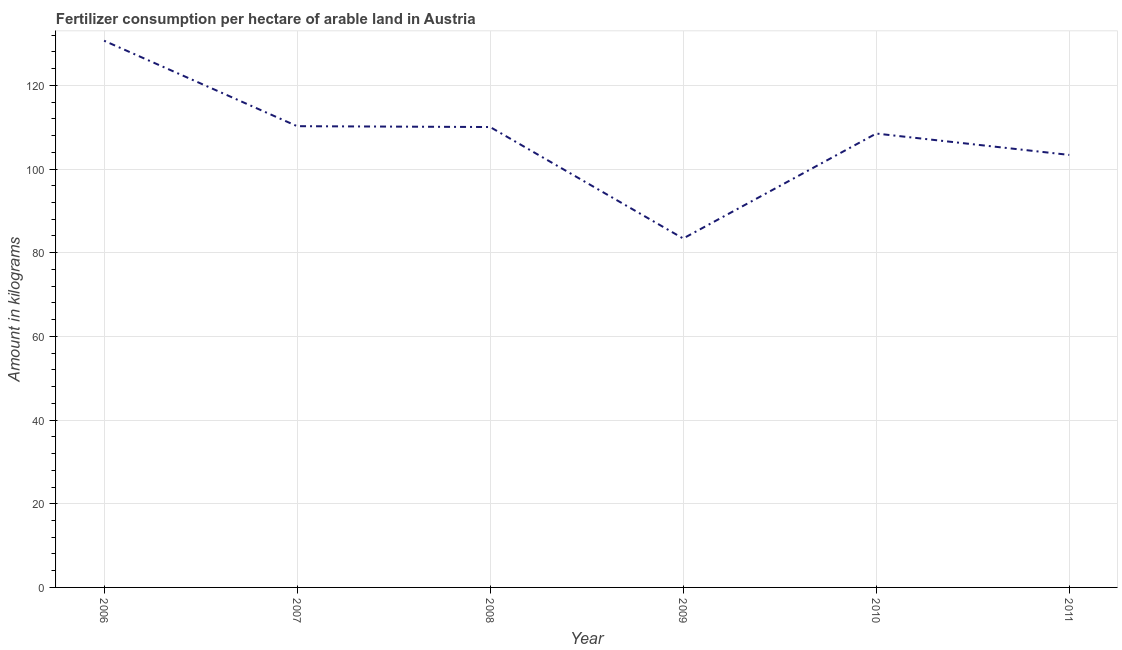What is the amount of fertilizer consumption in 2009?
Provide a succinct answer. 83.41. Across all years, what is the maximum amount of fertilizer consumption?
Give a very brief answer. 130.68. Across all years, what is the minimum amount of fertilizer consumption?
Give a very brief answer. 83.41. In which year was the amount of fertilizer consumption minimum?
Give a very brief answer. 2009. What is the sum of the amount of fertilizer consumption?
Ensure brevity in your answer.  646.25. What is the difference between the amount of fertilizer consumption in 2006 and 2007?
Offer a very short reply. 20.43. What is the average amount of fertilizer consumption per year?
Ensure brevity in your answer.  107.71. What is the median amount of fertilizer consumption?
Provide a short and direct response. 109.27. In how many years, is the amount of fertilizer consumption greater than 8 kg?
Provide a succinct answer. 6. Do a majority of the years between 2010 and 2009 (inclusive) have amount of fertilizer consumption greater than 128 kg?
Your response must be concise. No. What is the ratio of the amount of fertilizer consumption in 2007 to that in 2008?
Provide a short and direct response. 1. Is the amount of fertilizer consumption in 2008 less than that in 2010?
Provide a short and direct response. No. Is the difference between the amount of fertilizer consumption in 2007 and 2010 greater than the difference between any two years?
Your answer should be compact. No. What is the difference between the highest and the second highest amount of fertilizer consumption?
Your response must be concise. 20.43. Is the sum of the amount of fertilizer consumption in 2009 and 2010 greater than the maximum amount of fertilizer consumption across all years?
Your answer should be compact. Yes. What is the difference between the highest and the lowest amount of fertilizer consumption?
Offer a very short reply. 47.27. Are the values on the major ticks of Y-axis written in scientific E-notation?
Your answer should be compact. No. Does the graph contain any zero values?
Make the answer very short. No. What is the title of the graph?
Give a very brief answer. Fertilizer consumption per hectare of arable land in Austria . What is the label or title of the Y-axis?
Offer a terse response. Amount in kilograms. What is the Amount in kilograms of 2006?
Provide a short and direct response. 130.68. What is the Amount in kilograms of 2007?
Your answer should be compact. 110.25. What is the Amount in kilograms in 2008?
Your answer should be very brief. 110.05. What is the Amount in kilograms of 2009?
Your response must be concise. 83.41. What is the Amount in kilograms in 2010?
Give a very brief answer. 108.49. What is the Amount in kilograms in 2011?
Provide a short and direct response. 103.38. What is the difference between the Amount in kilograms in 2006 and 2007?
Give a very brief answer. 20.43. What is the difference between the Amount in kilograms in 2006 and 2008?
Give a very brief answer. 20.63. What is the difference between the Amount in kilograms in 2006 and 2009?
Your answer should be compact. 47.27. What is the difference between the Amount in kilograms in 2006 and 2010?
Offer a terse response. 22.19. What is the difference between the Amount in kilograms in 2006 and 2011?
Your answer should be compact. 27.3. What is the difference between the Amount in kilograms in 2007 and 2008?
Your response must be concise. 0.2. What is the difference between the Amount in kilograms in 2007 and 2009?
Offer a very short reply. 26.84. What is the difference between the Amount in kilograms in 2007 and 2010?
Your answer should be compact. 1.76. What is the difference between the Amount in kilograms in 2007 and 2011?
Provide a succinct answer. 6.87. What is the difference between the Amount in kilograms in 2008 and 2009?
Keep it short and to the point. 26.64. What is the difference between the Amount in kilograms in 2008 and 2010?
Provide a succinct answer. 1.56. What is the difference between the Amount in kilograms in 2008 and 2011?
Provide a short and direct response. 6.66. What is the difference between the Amount in kilograms in 2009 and 2010?
Keep it short and to the point. -25.08. What is the difference between the Amount in kilograms in 2009 and 2011?
Provide a succinct answer. -19.98. What is the difference between the Amount in kilograms in 2010 and 2011?
Your answer should be compact. 5.11. What is the ratio of the Amount in kilograms in 2006 to that in 2007?
Keep it short and to the point. 1.19. What is the ratio of the Amount in kilograms in 2006 to that in 2008?
Provide a short and direct response. 1.19. What is the ratio of the Amount in kilograms in 2006 to that in 2009?
Your response must be concise. 1.57. What is the ratio of the Amount in kilograms in 2006 to that in 2010?
Make the answer very short. 1.21. What is the ratio of the Amount in kilograms in 2006 to that in 2011?
Give a very brief answer. 1.26. What is the ratio of the Amount in kilograms in 2007 to that in 2009?
Provide a short and direct response. 1.32. What is the ratio of the Amount in kilograms in 2007 to that in 2010?
Ensure brevity in your answer.  1.02. What is the ratio of the Amount in kilograms in 2007 to that in 2011?
Make the answer very short. 1.07. What is the ratio of the Amount in kilograms in 2008 to that in 2009?
Offer a very short reply. 1.32. What is the ratio of the Amount in kilograms in 2008 to that in 2011?
Ensure brevity in your answer.  1.06. What is the ratio of the Amount in kilograms in 2009 to that in 2010?
Your answer should be very brief. 0.77. What is the ratio of the Amount in kilograms in 2009 to that in 2011?
Ensure brevity in your answer.  0.81. What is the ratio of the Amount in kilograms in 2010 to that in 2011?
Make the answer very short. 1.05. 